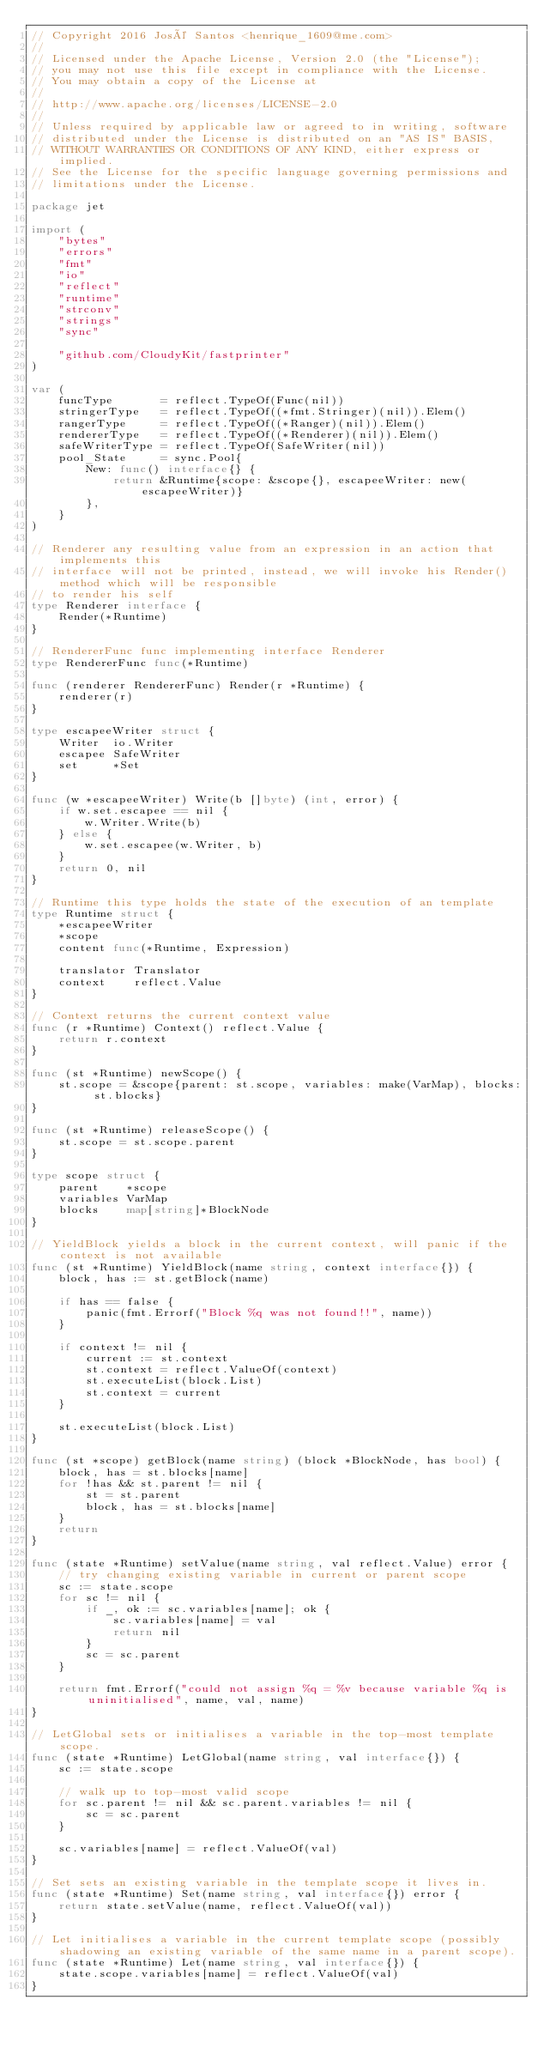Convert code to text. <code><loc_0><loc_0><loc_500><loc_500><_Go_>// Copyright 2016 José Santos <henrique_1609@me.com>
//
// Licensed under the Apache License, Version 2.0 (the "License");
// you may not use this file except in compliance with the License.
// You may obtain a copy of the License at
//
// http://www.apache.org/licenses/LICENSE-2.0
//
// Unless required by applicable law or agreed to in writing, software
// distributed under the License is distributed on an "AS IS" BASIS,
// WITHOUT WARRANTIES OR CONDITIONS OF ANY KIND, either express or implied.
// See the License for the specific language governing permissions and
// limitations under the License.

package jet

import (
	"bytes"
	"errors"
	"fmt"
	"io"
	"reflect"
	"runtime"
	"strconv"
	"strings"
	"sync"

	"github.com/CloudyKit/fastprinter"
)

var (
	funcType       = reflect.TypeOf(Func(nil))
	stringerType   = reflect.TypeOf((*fmt.Stringer)(nil)).Elem()
	rangerType     = reflect.TypeOf((*Ranger)(nil)).Elem()
	rendererType   = reflect.TypeOf((*Renderer)(nil)).Elem()
	safeWriterType = reflect.TypeOf(SafeWriter(nil))
	pool_State     = sync.Pool{
		New: func() interface{} {
			return &Runtime{scope: &scope{}, escapeeWriter: new(escapeeWriter)}
		},
	}
)

// Renderer any resulting value from an expression in an action that implements this
// interface will not be printed, instead, we will invoke his Render() method which will be responsible
// to render his self
type Renderer interface {
	Render(*Runtime)
}

// RendererFunc func implementing interface Renderer
type RendererFunc func(*Runtime)

func (renderer RendererFunc) Render(r *Runtime) {
	renderer(r)
}

type escapeeWriter struct {
	Writer  io.Writer
	escapee SafeWriter
	set     *Set
}

func (w *escapeeWriter) Write(b []byte) (int, error) {
	if w.set.escapee == nil {
		w.Writer.Write(b)
	} else {
		w.set.escapee(w.Writer, b)
	}
	return 0, nil
}

// Runtime this type holds the state of the execution of an template
type Runtime struct {
	*escapeeWriter
	*scope
	content func(*Runtime, Expression)

	translator Translator
	context    reflect.Value
}

// Context returns the current context value
func (r *Runtime) Context() reflect.Value {
	return r.context
}

func (st *Runtime) newScope() {
	st.scope = &scope{parent: st.scope, variables: make(VarMap), blocks: st.blocks}
}

func (st *Runtime) releaseScope() {
	st.scope = st.scope.parent
}

type scope struct {
	parent    *scope
	variables VarMap
	blocks    map[string]*BlockNode
}

// YieldBlock yields a block in the current context, will panic if the context is not available
func (st *Runtime) YieldBlock(name string, context interface{}) {
	block, has := st.getBlock(name)

	if has == false {
		panic(fmt.Errorf("Block %q was not found!!", name))
	}

	if context != nil {
		current := st.context
		st.context = reflect.ValueOf(context)
		st.executeList(block.List)
		st.context = current
	}

	st.executeList(block.List)
}

func (st *scope) getBlock(name string) (block *BlockNode, has bool) {
	block, has = st.blocks[name]
	for !has && st.parent != nil {
		st = st.parent
		block, has = st.blocks[name]
	}
	return
}

func (state *Runtime) setValue(name string, val reflect.Value) error {
	// try changing existing variable in current or parent scope
	sc := state.scope
	for sc != nil {
		if _, ok := sc.variables[name]; ok {
			sc.variables[name] = val
			return nil
		}
		sc = sc.parent
	}

	return fmt.Errorf("could not assign %q = %v because variable %q is uninitialised", name, val, name)
}

// LetGlobal sets or initialises a variable in the top-most template scope.
func (state *Runtime) LetGlobal(name string, val interface{}) {
	sc := state.scope

	// walk up to top-most valid scope
	for sc.parent != nil && sc.parent.variables != nil {
		sc = sc.parent
	}

	sc.variables[name] = reflect.ValueOf(val)
}

// Set sets an existing variable in the template scope it lives in.
func (state *Runtime) Set(name string, val interface{}) error {
	return state.setValue(name, reflect.ValueOf(val))
}

// Let initialises a variable in the current template scope (possibly shadowing an existing variable of the same name in a parent scope).
func (state *Runtime) Let(name string, val interface{}) {
	state.scope.variables[name] = reflect.ValueOf(val)
}
</code> 